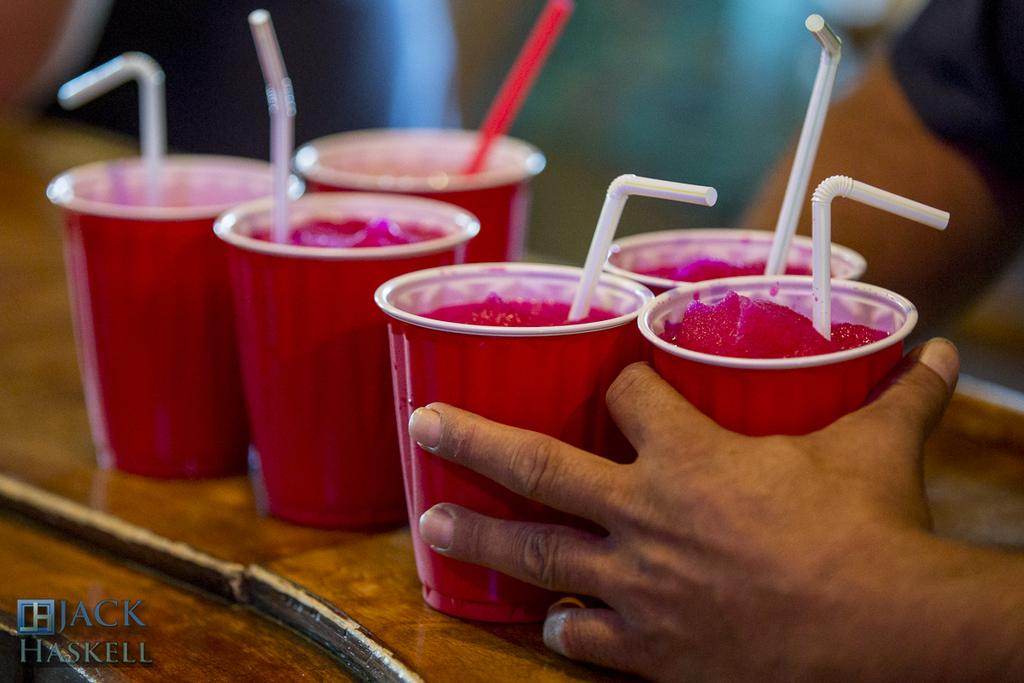What type of dessert is in the disposal tumblers in the image? There are sorbets in disposal tumblers in the image. What can be used to drink the sorbets in the image? There are straws in the image that can be used to drink the sorbets. Where are the sorbets and straws placed in the image? The sorbets and straws are placed on a table in the image. Who is holding the tumblers in the image? There is a person holding the tumblers in the image. What type of marble is visible on the table in the image? There is no marble visible on the table in the image; it is a regular table. Can you see a rabbit hopping around the sorbets in the image? There is no rabbit present in the image; it only features sorbets, straws, a table, and a person holding the tumblers. 